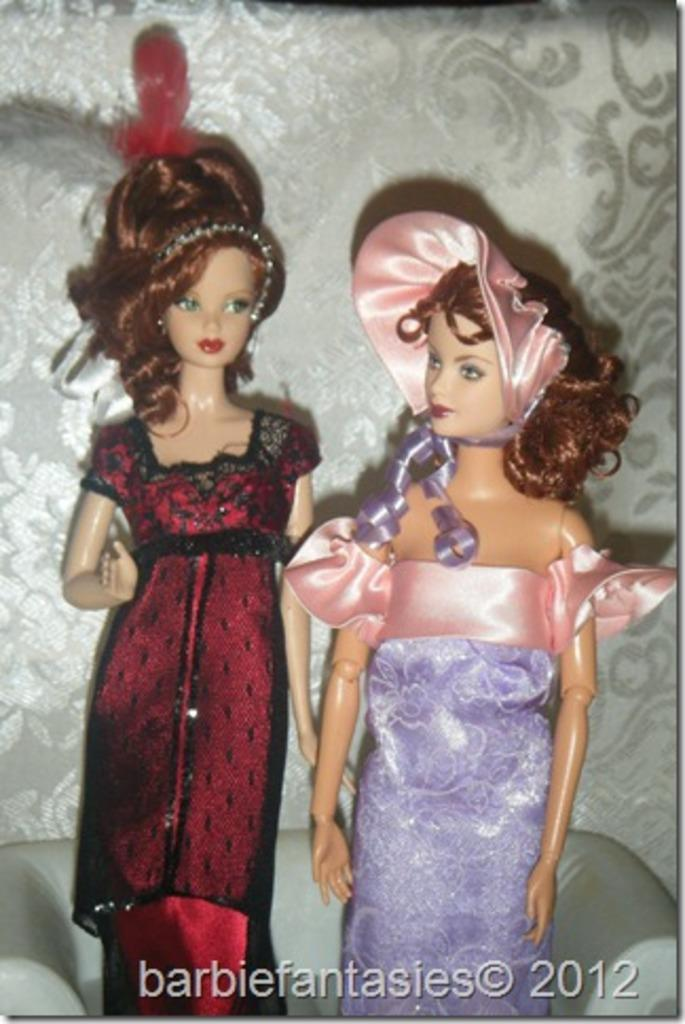What type of dolls are in the image? There are two Barbie dolls in the image. Where are the dolls located? The dolls are on a sofa. What can be seen in the background of the image? There is a wall in the background of the image. Is there any text present in the image? Yes, there is some text written at the bottom of the image. Can you see any rocks near the lake in the image? There is no lake or rocks present in the image; it features two Barbie dolls on a sofa with a wall in the background and some text at the bottom. 